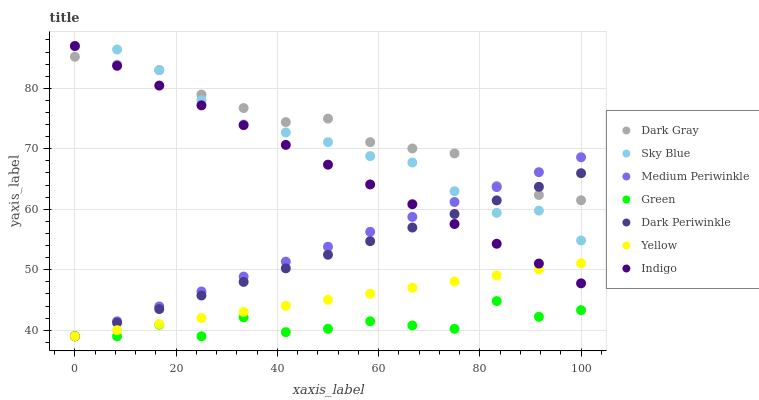Does Green have the minimum area under the curve?
Answer yes or no. Yes. Does Dark Gray have the maximum area under the curve?
Answer yes or no. Yes. Does Medium Periwinkle have the minimum area under the curve?
Answer yes or no. No. Does Medium Periwinkle have the maximum area under the curve?
Answer yes or no. No. Is Dark Periwinkle the smoothest?
Answer yes or no. Yes. Is Green the roughest?
Answer yes or no. Yes. Is Medium Periwinkle the smoothest?
Answer yes or no. No. Is Medium Periwinkle the roughest?
Answer yes or no. No. Does Medium Periwinkle have the lowest value?
Answer yes or no. Yes. Does Dark Gray have the lowest value?
Answer yes or no. No. Does Sky Blue have the highest value?
Answer yes or no. Yes. Does Medium Periwinkle have the highest value?
Answer yes or no. No. Is Green less than Sky Blue?
Answer yes or no. Yes. Is Dark Gray greater than Green?
Answer yes or no. Yes. Does Sky Blue intersect Medium Periwinkle?
Answer yes or no. Yes. Is Sky Blue less than Medium Periwinkle?
Answer yes or no. No. Is Sky Blue greater than Medium Periwinkle?
Answer yes or no. No. Does Green intersect Sky Blue?
Answer yes or no. No. 